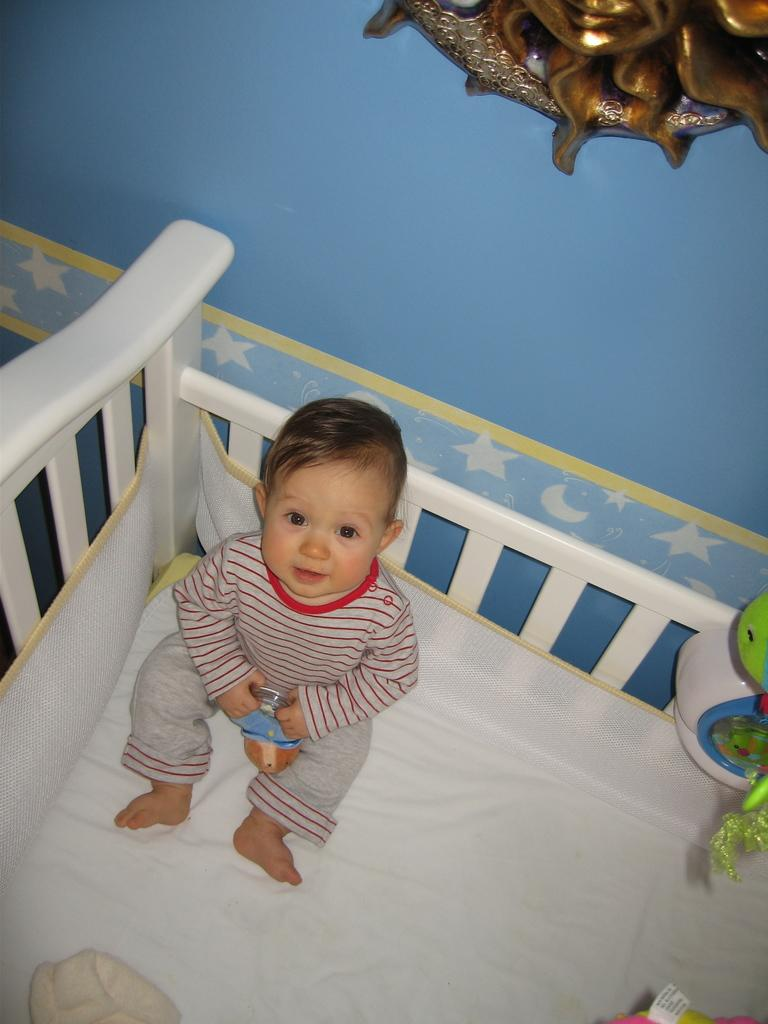What is the baby doing in the image? The baby is sitting on a bed in the image. What is the baby holding in the image? The baby is holding a toy in the image. What can be seen on the wall in the image? There is a decorative object on a blue wall, and there are pictures of stars and moons on the wall. What type of music can be heard coming from the baby's toy in the image? There is no indication in the image that the baby's toy is making any sounds, let alone music. 